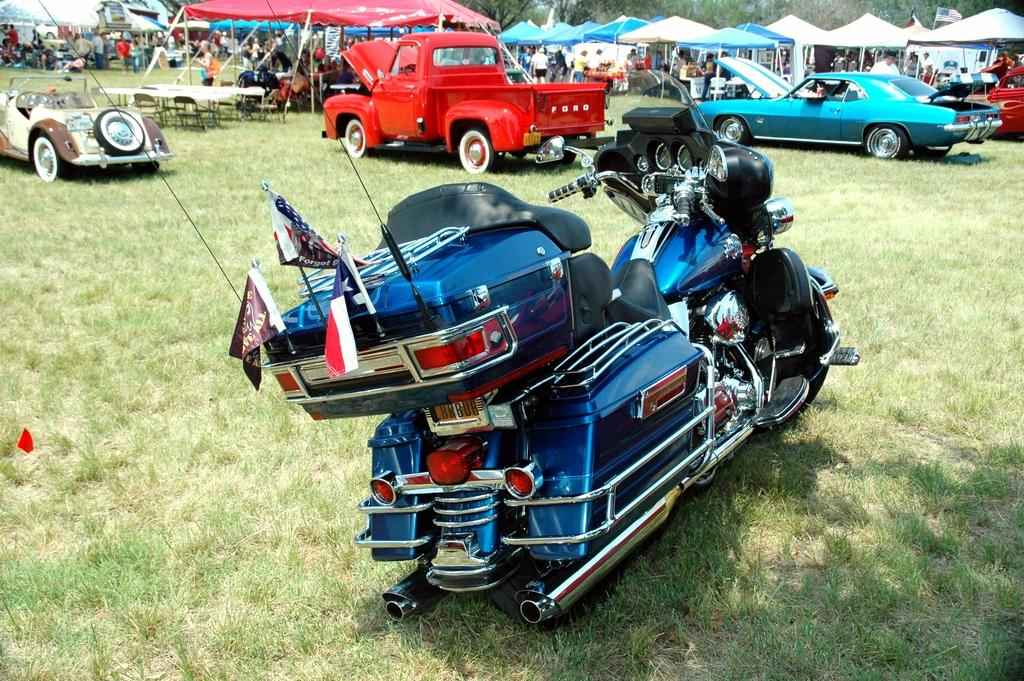What is the main subject in the center of the image? There is a bike in the center of the image. Where is the bike located? The bike is on the grass. What can be seen in the background of the image? There are cars, tents, persons, tables, chairs, and trees in the background of the image. What type of wax is being used to polish the bike in the image? There is no indication in the image that the bike is being polished or that wax is being used. 